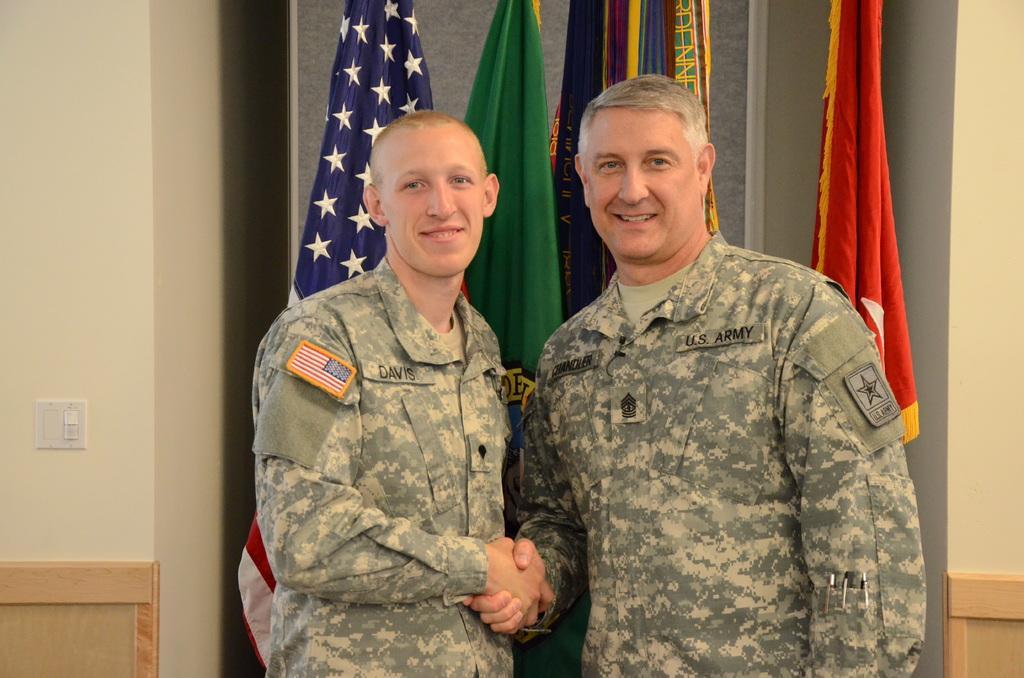Can you describe this image briefly? In this image, in the middle, we can see two men are shaking their hands to each other. In the background, we can see some flags, wall and a switchboard. 